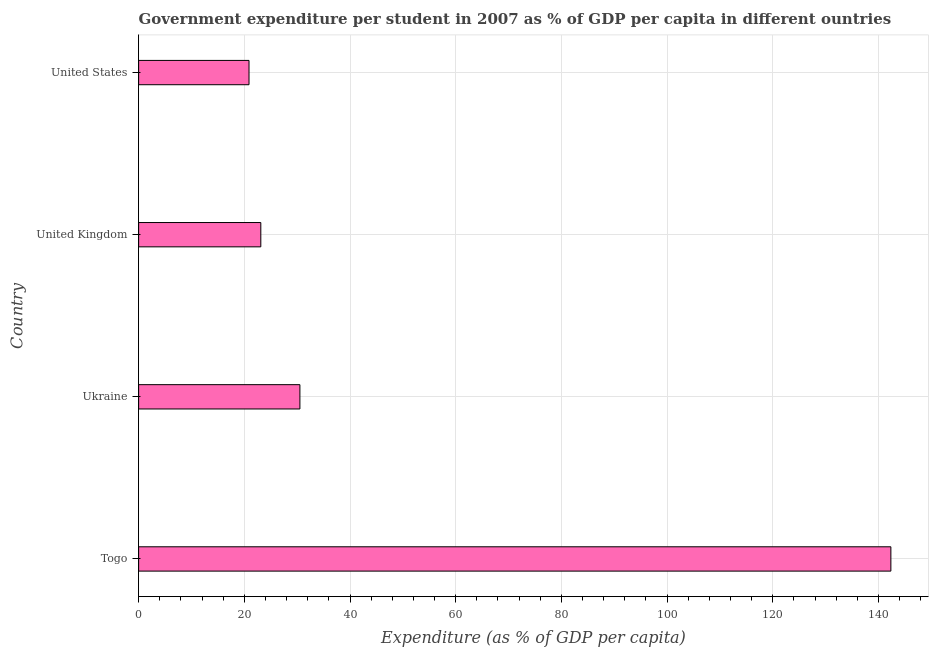Does the graph contain grids?
Make the answer very short. Yes. What is the title of the graph?
Keep it short and to the point. Government expenditure per student in 2007 as % of GDP per capita in different ountries. What is the label or title of the X-axis?
Your answer should be very brief. Expenditure (as % of GDP per capita). What is the label or title of the Y-axis?
Make the answer very short. Country. What is the government expenditure per student in Ukraine?
Ensure brevity in your answer.  30.52. Across all countries, what is the maximum government expenditure per student?
Your answer should be very brief. 142.35. Across all countries, what is the minimum government expenditure per student?
Provide a succinct answer. 20.89. In which country was the government expenditure per student maximum?
Offer a terse response. Togo. In which country was the government expenditure per student minimum?
Ensure brevity in your answer.  United States. What is the sum of the government expenditure per student?
Keep it short and to the point. 216.88. What is the difference between the government expenditure per student in Togo and United States?
Keep it short and to the point. 121.46. What is the average government expenditure per student per country?
Your response must be concise. 54.22. What is the median government expenditure per student?
Provide a succinct answer. 26.82. What is the ratio of the government expenditure per student in United Kingdom to that in United States?
Your answer should be very brief. 1.11. Is the government expenditure per student in Togo less than that in Ukraine?
Ensure brevity in your answer.  No. What is the difference between the highest and the second highest government expenditure per student?
Offer a terse response. 111.83. What is the difference between the highest and the lowest government expenditure per student?
Offer a very short reply. 121.46. In how many countries, is the government expenditure per student greater than the average government expenditure per student taken over all countries?
Make the answer very short. 1. How many bars are there?
Offer a very short reply. 4. Are all the bars in the graph horizontal?
Offer a very short reply. Yes. How many countries are there in the graph?
Your response must be concise. 4. What is the difference between two consecutive major ticks on the X-axis?
Your answer should be compact. 20. Are the values on the major ticks of X-axis written in scientific E-notation?
Give a very brief answer. No. What is the Expenditure (as % of GDP per capita) in Togo?
Give a very brief answer. 142.35. What is the Expenditure (as % of GDP per capita) of Ukraine?
Keep it short and to the point. 30.52. What is the Expenditure (as % of GDP per capita) in United Kingdom?
Your response must be concise. 23.12. What is the Expenditure (as % of GDP per capita) in United States?
Your response must be concise. 20.89. What is the difference between the Expenditure (as % of GDP per capita) in Togo and Ukraine?
Your answer should be compact. 111.83. What is the difference between the Expenditure (as % of GDP per capita) in Togo and United Kingdom?
Provide a succinct answer. 119.23. What is the difference between the Expenditure (as % of GDP per capita) in Togo and United States?
Offer a terse response. 121.46. What is the difference between the Expenditure (as % of GDP per capita) in Ukraine and United Kingdom?
Ensure brevity in your answer.  7.4. What is the difference between the Expenditure (as % of GDP per capita) in Ukraine and United States?
Make the answer very short. 9.63. What is the difference between the Expenditure (as % of GDP per capita) in United Kingdom and United States?
Your answer should be compact. 2.23. What is the ratio of the Expenditure (as % of GDP per capita) in Togo to that in Ukraine?
Give a very brief answer. 4.66. What is the ratio of the Expenditure (as % of GDP per capita) in Togo to that in United Kingdom?
Make the answer very short. 6.16. What is the ratio of the Expenditure (as % of GDP per capita) in Togo to that in United States?
Your answer should be very brief. 6.82. What is the ratio of the Expenditure (as % of GDP per capita) in Ukraine to that in United Kingdom?
Offer a terse response. 1.32. What is the ratio of the Expenditure (as % of GDP per capita) in Ukraine to that in United States?
Give a very brief answer. 1.46. What is the ratio of the Expenditure (as % of GDP per capita) in United Kingdom to that in United States?
Your answer should be compact. 1.11. 